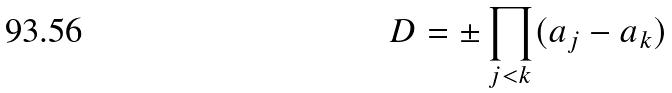<formula> <loc_0><loc_0><loc_500><loc_500>D = \pm \prod _ { j < k } ( a _ { j } - a _ { k } )</formula> 